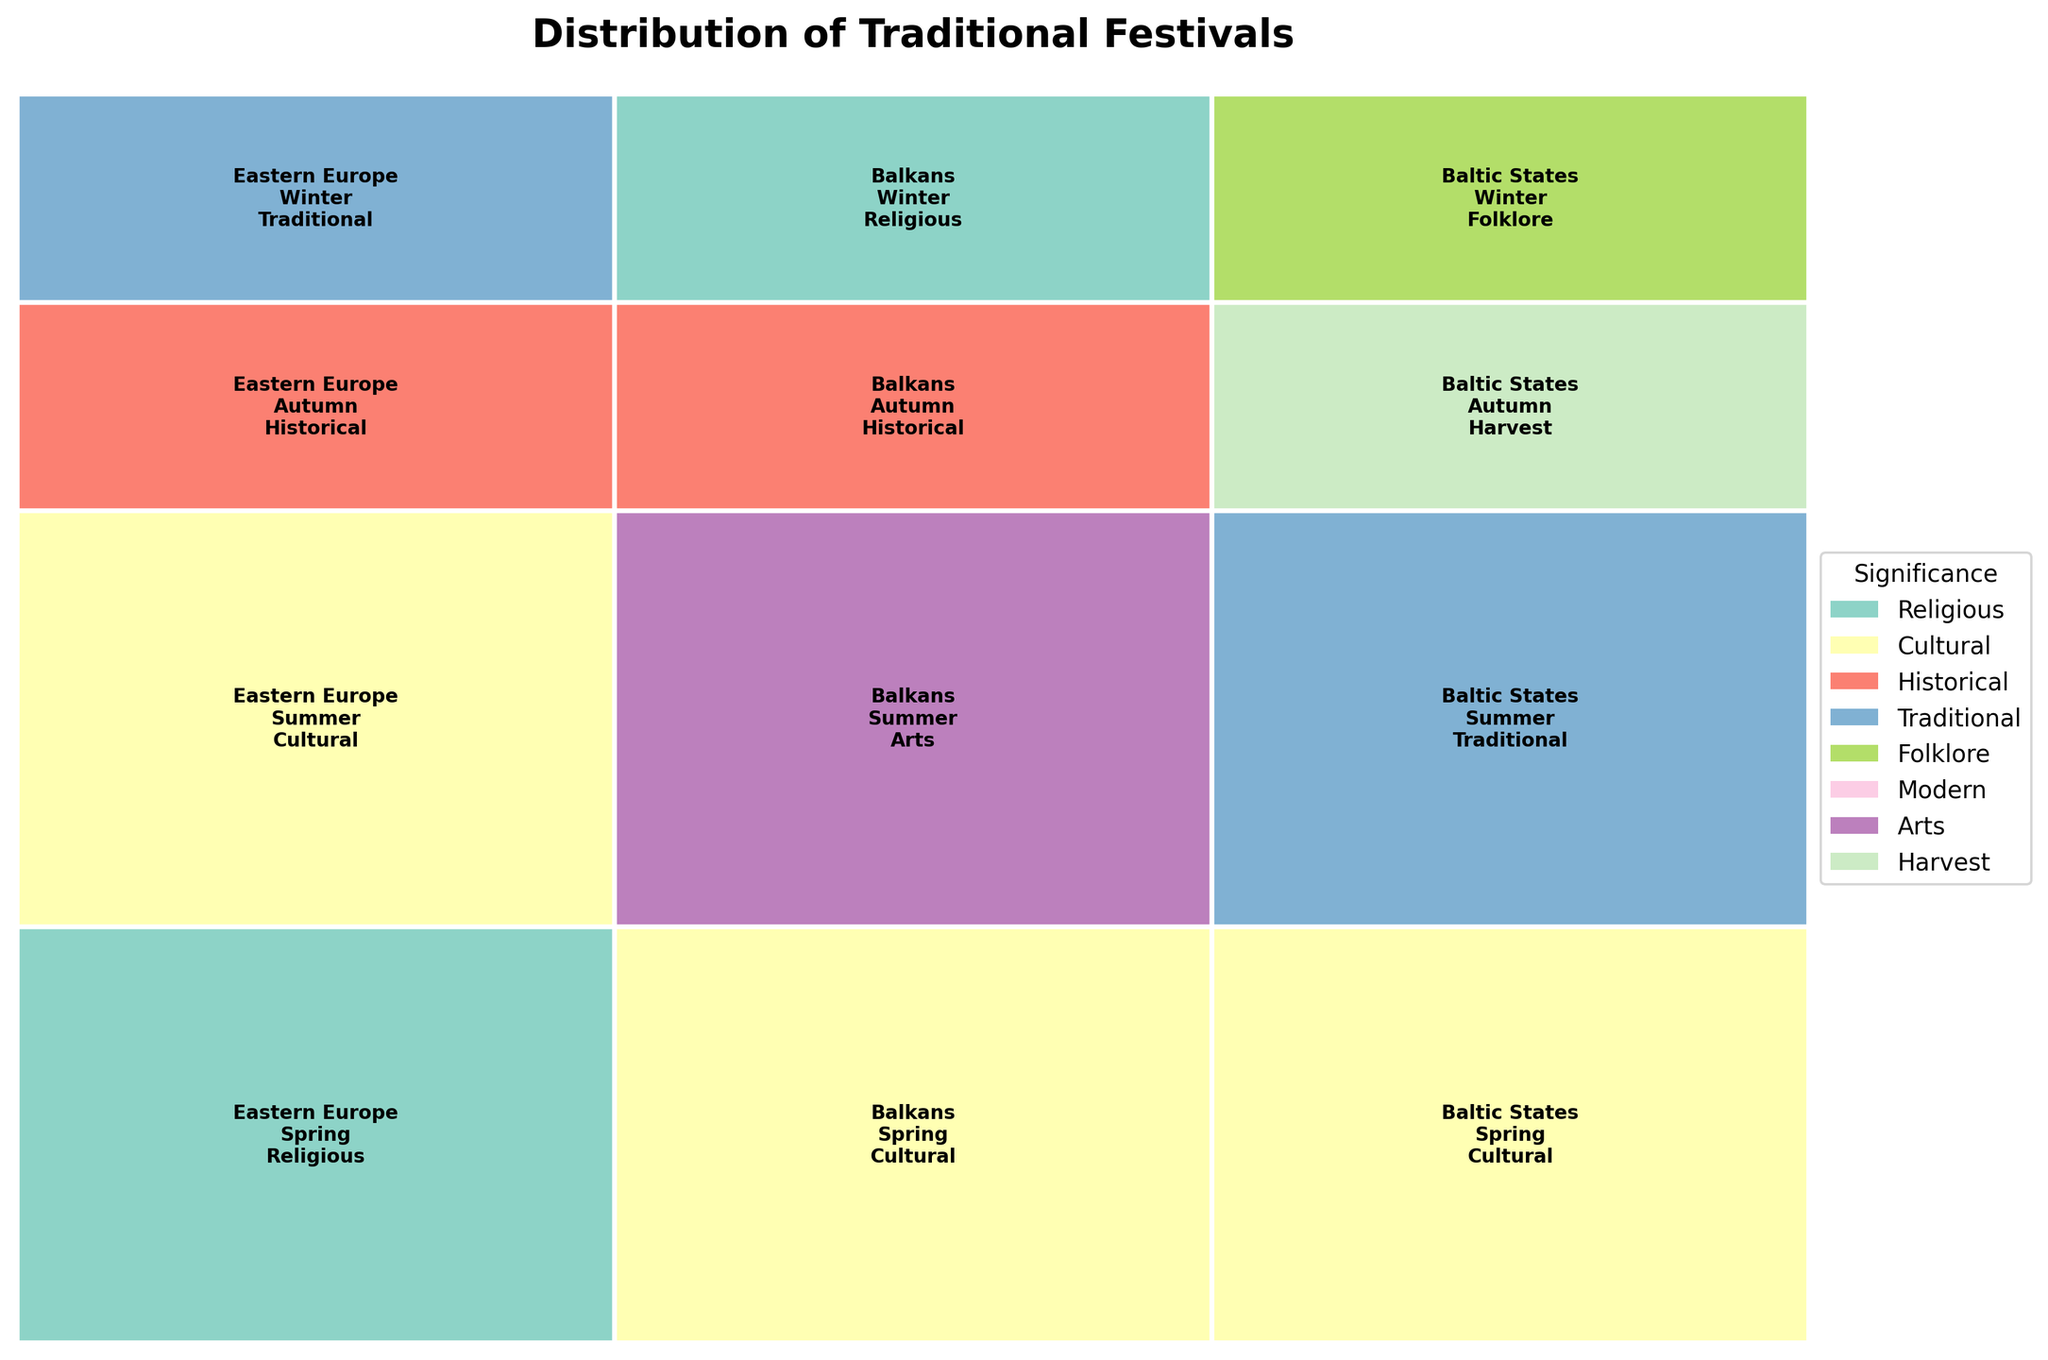How many festivals in Eastern Europe are held in the spring season? To find the number of spring festivals in Eastern Europe, look for the "Eastern Europe" region and the "Spring" season in the plot. Count the festivals listed. There are two: "Jare Święto" and "Busójárás."
Answer: 2 Which region has the highest number of festivals categorized as 'Cultural'? Identify the color representing 'Cultural' in the legend. Then, count the rectangles coloured this way for each region. Both Eastern Europe and the Baltic States have two festivals marked as 'Cultural'.
Answer: Eastern Europe and Baltic States Is there any 'Modern' festival in the winter season in the plot? Look for the winter section of the plot and check if any festivals listed are categorized as 'Modern' by referring to the legend. There are no winter festivals labeled 'Modern.'
Answer: No Which subregion in the Balkans celebrates a 'Historical' festival in autumn? Navigate to the 'Balkans' section in autumn, look for rectangles, and check for the categorization 'Historical'. In the Balkans, Greece celebrates 'Ohi Day' in autumn.
Answer: Greece How many subregions in the Baltic States have festivals that occur during the spring season? Go to the Baltic States region and tally the number of distinct subregions listed under the 'Spring' season. Lithuania and Estonia have spring festivals.
Answer: 2 Which season has the most diversity in festival significance? Assess each season for the number of unique significance categories represented. Autumn and Winter each have four types of significance: 'Historical,' 'Traditional,' 'Folklore,' and 'Harvest' in autumn and 'Religious,' 'Historical,' 'Traditional,' and 'Folklore' in winter.
Answer: Autumn and Winter Is there any 'Arts' festival during the spring season? Refer to the legend to identify the color for 'Arts' and then look within the 'Spring' section of the plot. There are no spring festivals labeled 'Arts.'
Answer: No Which region has festivals with the most diverse significance in the summer season? Examine the summer section of each region and count the number of unique significance categories. The Balkans and Baltic States each have festivals under different significance categories in the summer season.
Answer: Balkans and Baltic States Is there any overlap in the significance of festivals between Poland and Croatia? Identify the festivals in Poland and Croatia, noting their significance categories. Compare categories. Both have festivals categorized as 'Cultural.'
Answer: Yes How many 'Traditional' festivals are there in the plot? Search for the color associated with 'Traditional' listed in the legend and count the rectangles in the plot of that color. There are five 'Traditional' festivals.
Answer: 5 